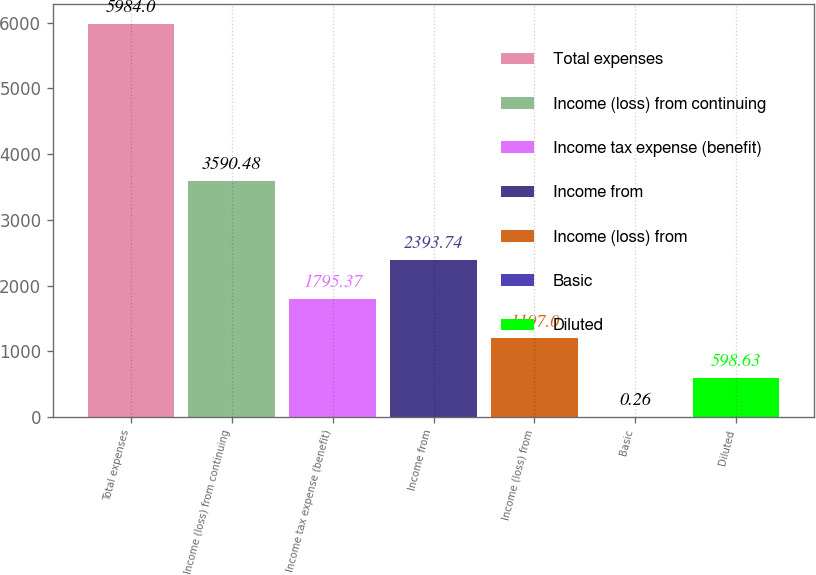Convert chart to OTSL. <chart><loc_0><loc_0><loc_500><loc_500><bar_chart><fcel>Total expenses<fcel>Income (loss) from continuing<fcel>Income tax expense (benefit)<fcel>Income from<fcel>Income (loss) from<fcel>Basic<fcel>Diluted<nl><fcel>5984<fcel>3590.48<fcel>1795.37<fcel>2393.74<fcel>1197<fcel>0.26<fcel>598.63<nl></chart> 